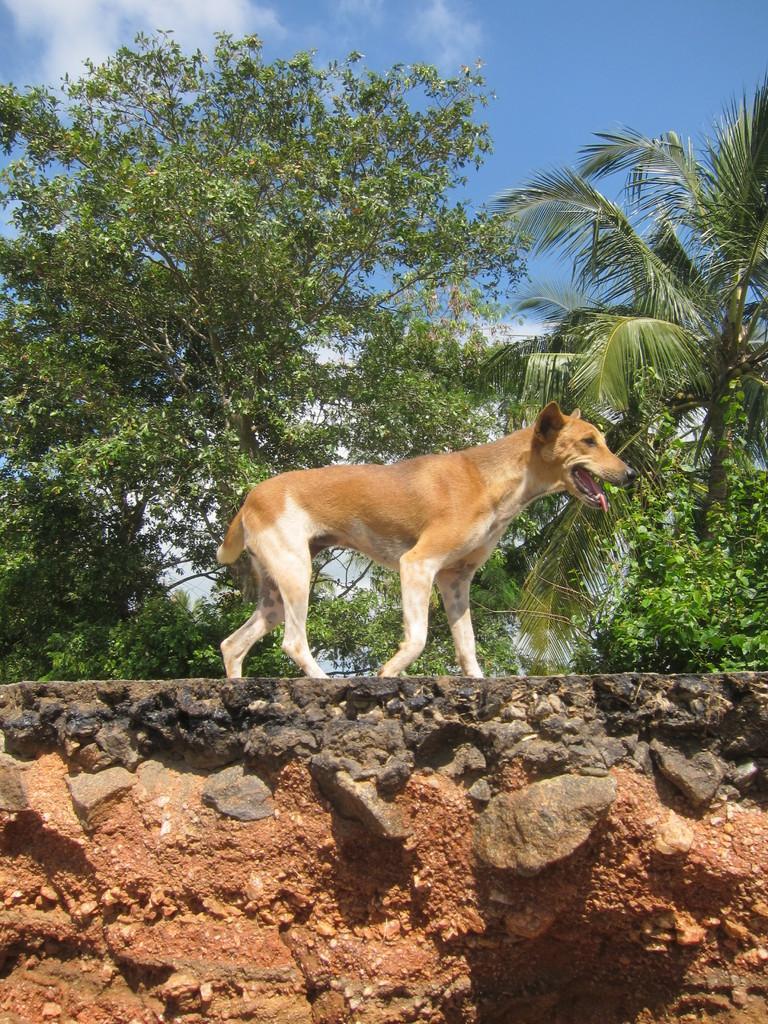How would you summarize this image in a sentence or two? In this image we can see a dog. Behind the dog, trees are present. The sky is in blue color with clouds. At the bottom of the image we can see rocks and sand. 